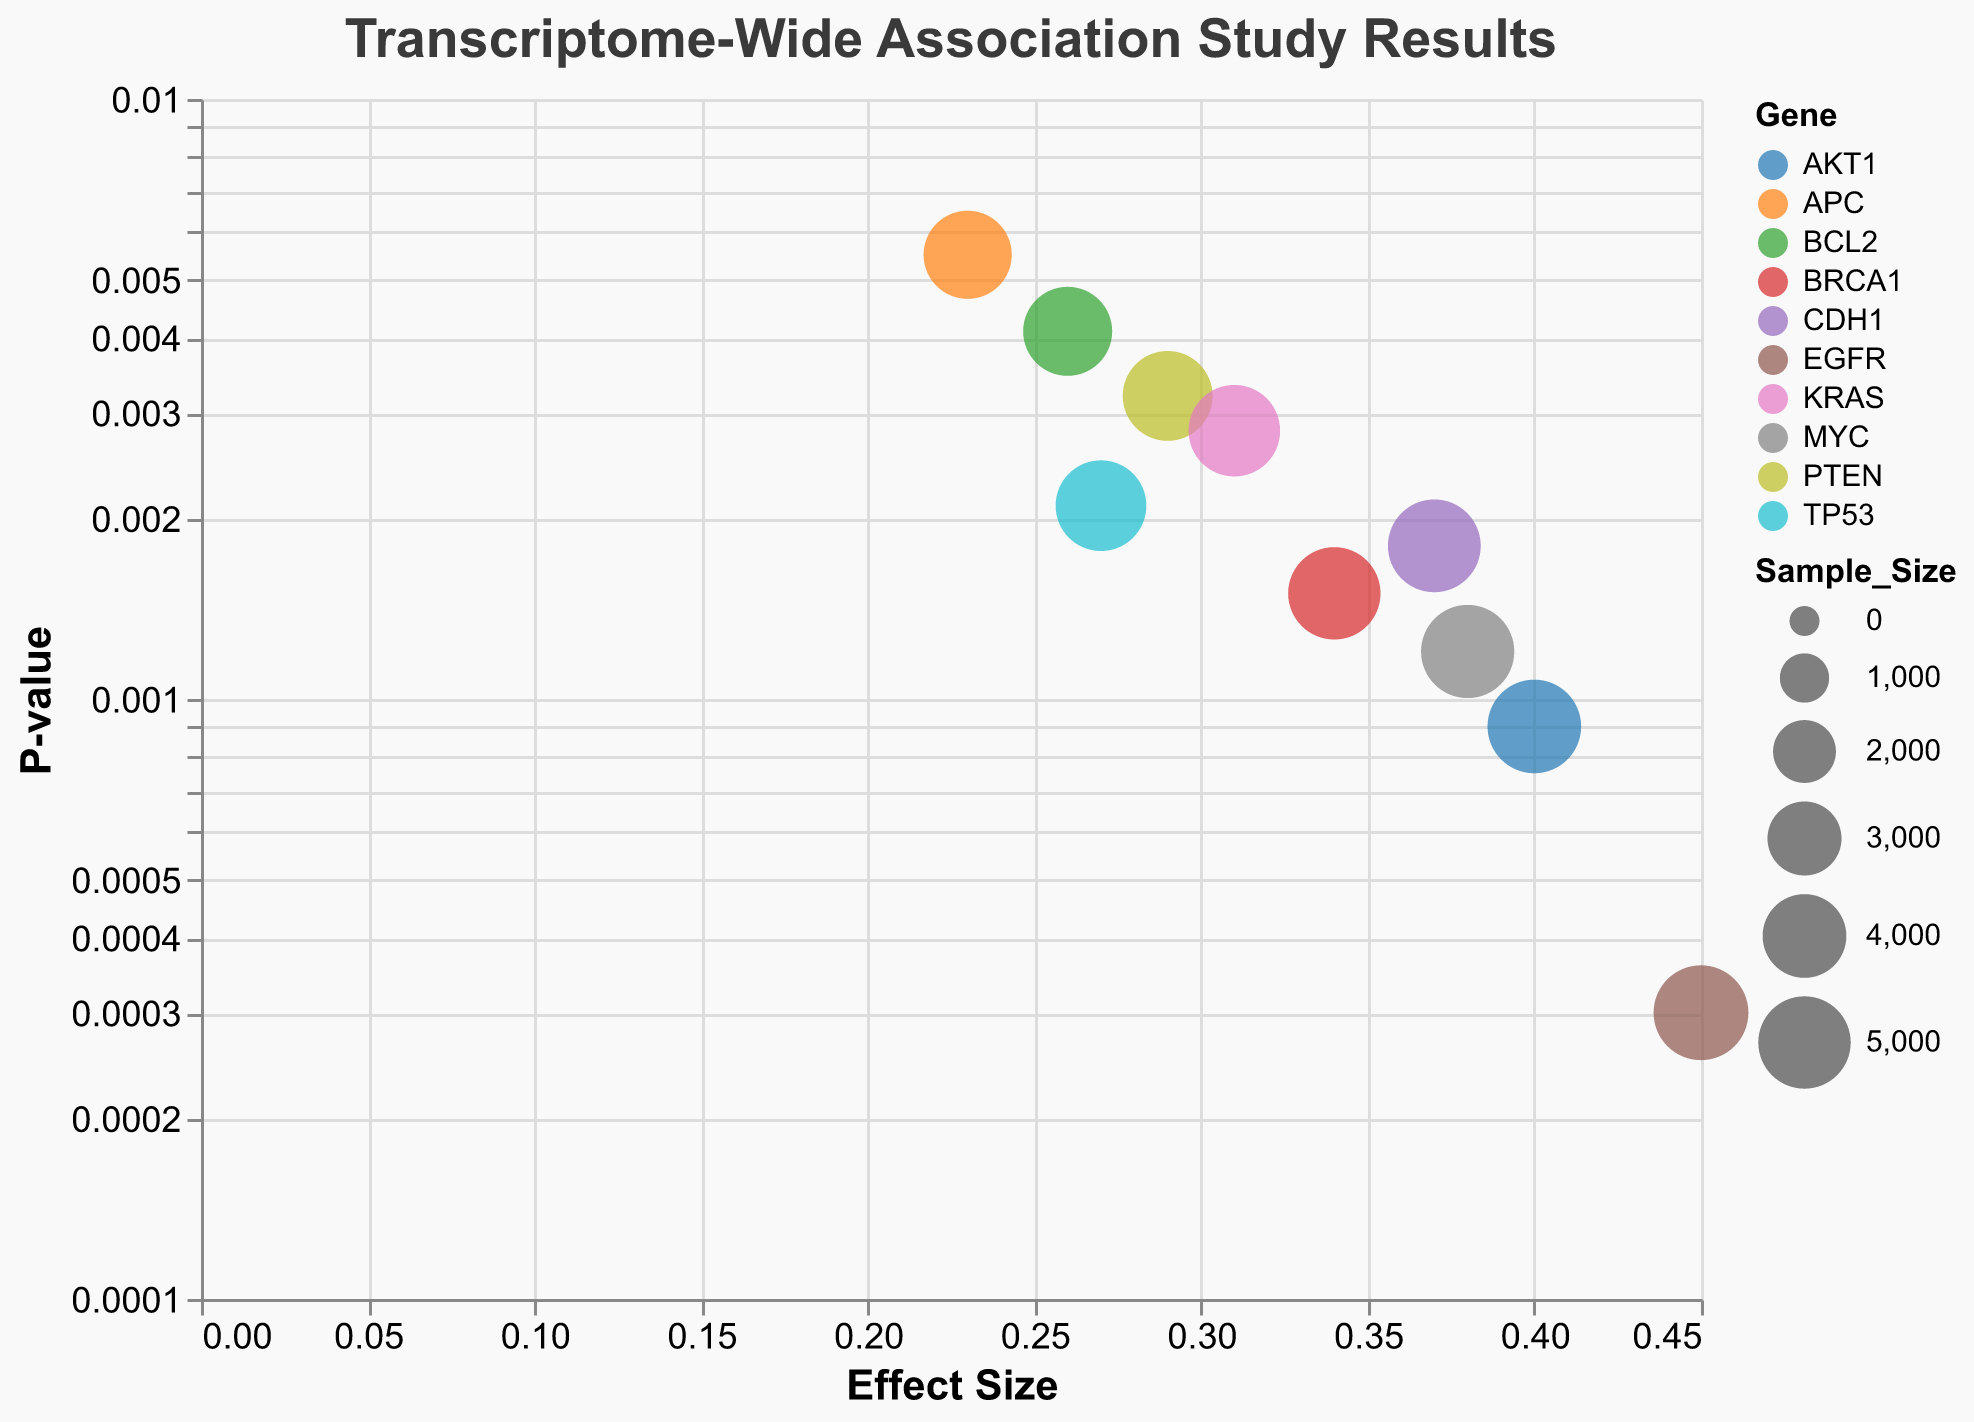What is the title of the plot? The title of a plot is usually displayed at the top and gives a quick understanding of what is being visualized. Here, the plot's title indicates it's about Transcriptome-Wide Association Study Results.
Answer: Transcriptome-Wide Association Study Results Which gene has the highest effect size? By checking the x-axis, which represents the effect size, and finding the data point farthest to the right, we can identify the gene with the highest effect size. In this case, the farthest right data point corresponds to EGFR with an effect size of 0.45.
Answer: EGFR What is the range of sample sizes in this plot? Reviewing the sizes of the bubbles can indicate the range of the sample sizes. The smallest sample size is 4500 (APC), and the largest is 5300 (EGFR).
Answer: 4500 to 5300 Which gene has the smallest P-value? Checking the y-axis, which represents P-values on a logarithmic scale, we identify the data point closest to the bottom. The smallest P-value is for EGFR at 0.0003.
Answer: EGFR How does the size of the AKT1 bubble compare to the APC bubble? This comparison involves evaluating the relative sizes of the bubbles for AKT1 and APC. The AKT1 bubble is significantly larger than the APC bubble because AKT1 has a sample size of 5150 while APC has a sample size of 4500.
Answer: Larger Which gene has the second highest effect size? The second highest effect size can be determined by looking for the bubble that is the second farthest to the right. This gene is AKT1 with an effect size of 0.40.
Answer: AKT1 What is the effect size of BRCA1? To find the effect size of BRCA1, locate its corresponding bubble and refer to its position along the x-axis. BRCA1 has an effect size of 0.34.
Answer: 0.34 Which gene has a P-value of 0.0012? By examining the y-axis and identifying the bubble at the position corresponding to a P-value of 0.0012, we find the gene MYC.
Answer: MYC Are there any genes with a sample size of exactly 5000? By examining the tooltip or the size of the bubbles, we can identify the gene with this sample size. BRCA1 has a sample size of exactly 5000.
Answer: BRCA1 Is there any gene with both a high effect size and a low P-value? If yes, which one? High effect size is indicated by the far right position along the x-axis and low P-value by the lower position along the y-axis. EGFR fits both criteria with an effect size of 0.45 and a P-value of 0.0003.
Answer: EGFR 